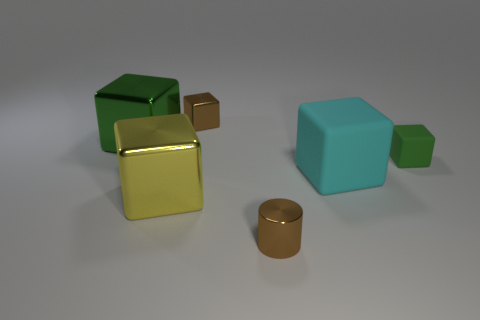Do the small metallic block and the tiny metal cylinder have the same color?
Provide a short and direct response. Yes. Do the brown thing that is behind the large yellow metal object and the cube on the right side of the large cyan block have the same material?
Offer a very short reply. No. How many things are tiny blocks or tiny metallic things that are on the left side of the tiny brown cylinder?
Your answer should be very brief. 2. Is there any other thing that is the same material as the big green thing?
Offer a very short reply. Yes. What shape is the tiny shiny object that is the same color as the small shiny cylinder?
Offer a very short reply. Cube. What is the material of the brown cylinder?
Offer a terse response. Metal. Does the brown cube have the same material as the tiny cylinder?
Ensure brevity in your answer.  Yes. How many matte things are either large green blocks or large objects?
Your answer should be compact. 1. There is a brown shiny thing that is behind the green matte thing; what shape is it?
Your response must be concise. Cube. There is a cyan block that is the same material as the tiny green thing; what is its size?
Your answer should be very brief. Large. 